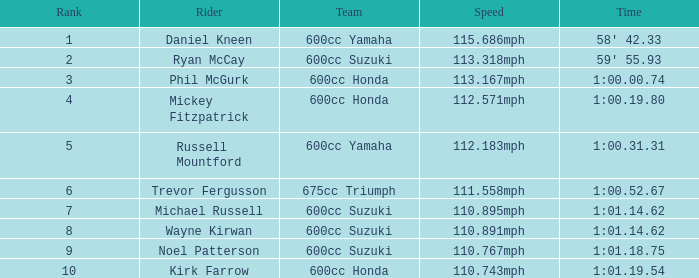1 1.0. 